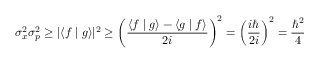Convert formula to latex. <formula><loc_0><loc_0><loc_500><loc_500>\sigma _ { x } ^ { 2 } \sigma _ { p } ^ { 2 } \geq | \langle f | g \rangle | ^ { 2 } \geq \left ( { \frac { \langle f | g \rangle - \langle g | f \rangle } { 2 i } } \right ) ^ { 2 } = \left ( { \frac { i } { 2 i } } \right ) ^ { 2 } = { \frac { \hbar { ^ } { 2 } } { 4 } }</formula> 